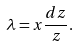<formula> <loc_0><loc_0><loc_500><loc_500>\lambda = x \frac { d z } { z } .</formula> 